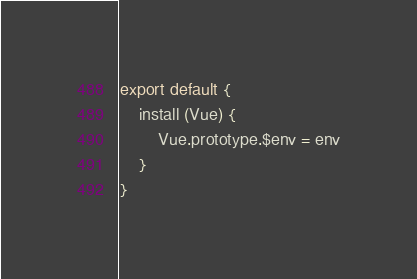Convert code to text. <code><loc_0><loc_0><loc_500><loc_500><_JavaScript_>
export default {
    install (Vue) {
        Vue.prototype.$env = env
    }
}</code> 